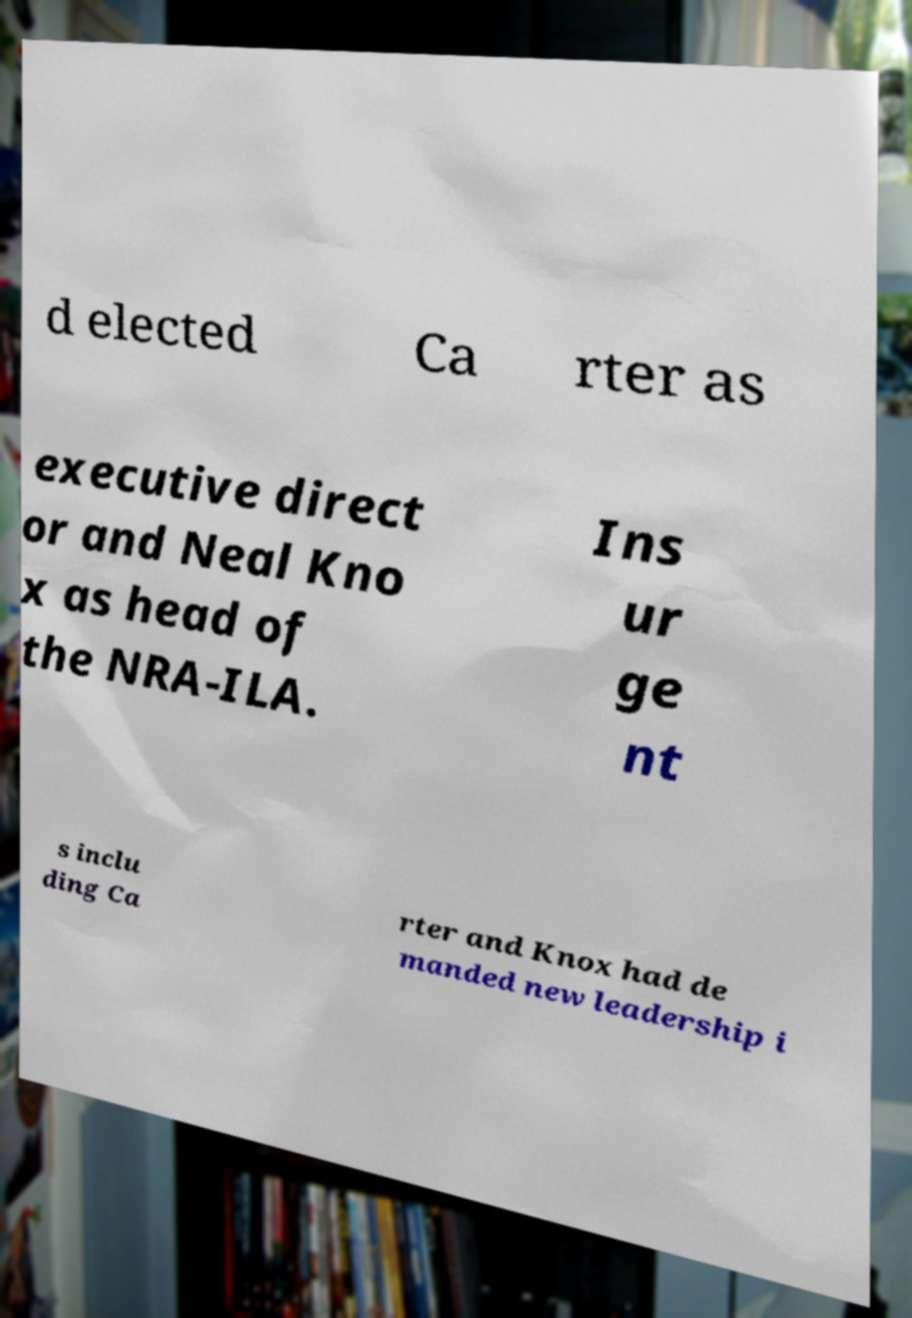There's text embedded in this image that I need extracted. Can you transcribe it verbatim? d elected Ca rter as executive direct or and Neal Kno x as head of the NRA-ILA. Ins ur ge nt s inclu ding Ca rter and Knox had de manded new leadership i 